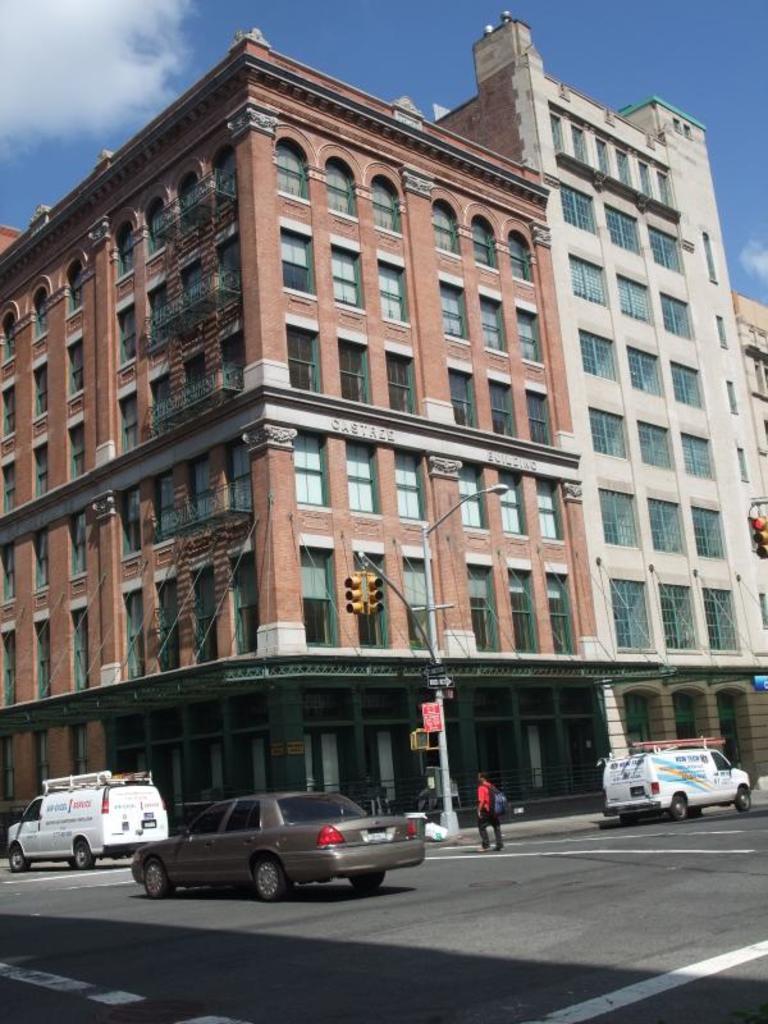How would you summarize this image in a sentence or two? In the picture we can see buildings with windows and glasses to it and near to the building we can see a pole with light and one pole with traffic light and on the road we can see some vehicles and a man standing near to the path wearing a bag, and in the background we can see the sky with clouds. 